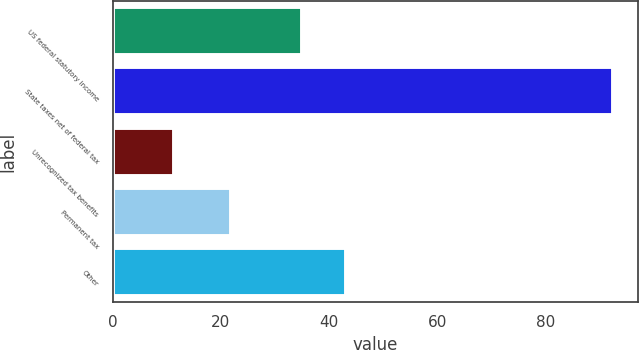Convert chart to OTSL. <chart><loc_0><loc_0><loc_500><loc_500><bar_chart><fcel>US federal statutory income<fcel>State taxes net of federal tax<fcel>Unrecognized tax benefits<fcel>Permanent tax<fcel>Other<nl><fcel>35<fcel>92.5<fcel>11.4<fcel>21.8<fcel>43.11<nl></chart> 